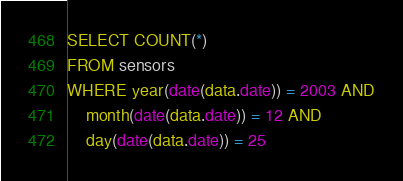<code> <loc_0><loc_0><loc_500><loc_500><_SQL_>SELECT COUNT(*)
FROM sensors
WHERE year(date(data.date)) = 2003 AND
    month(date(data.date)) = 12 AND
    day(date(data.date)) = 25
</code> 